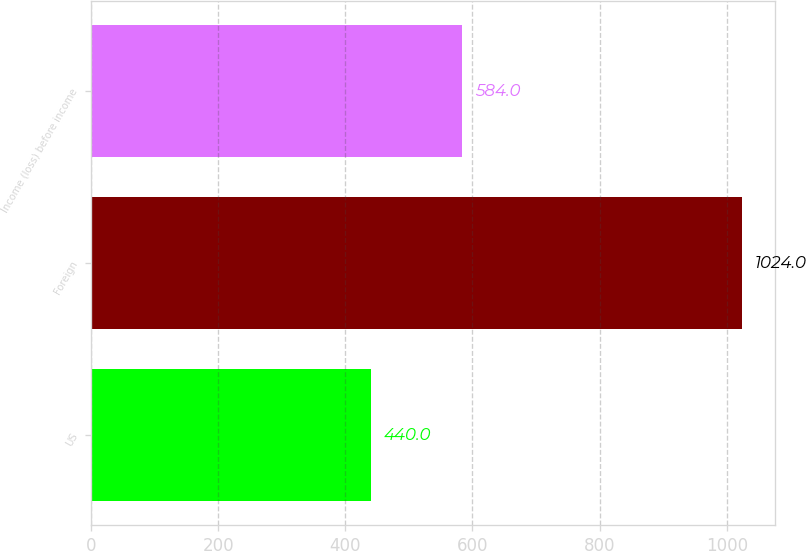<chart> <loc_0><loc_0><loc_500><loc_500><bar_chart><fcel>US<fcel>Foreign<fcel>Income (loss) before income<nl><fcel>440<fcel>1024<fcel>584<nl></chart> 